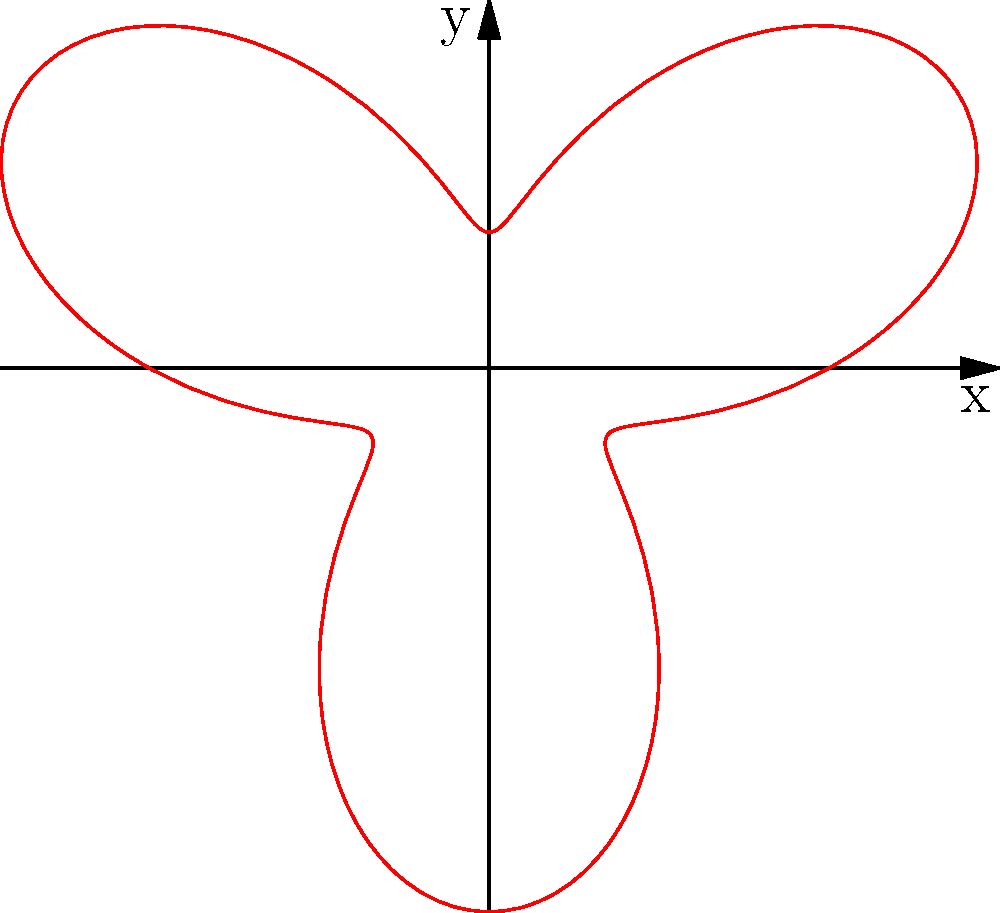In memory of your father, you plan to release a memorial balloon during a ceremony at the 9/11 Memorial. The balloon's trajectory can be modeled using the polar equation $r = 5 + 3\sin(3\theta)$, where $r$ is in meters and $\theta$ is in radians. What is the maximum distance, in meters, that the balloon will reach from the release point? To find the maximum distance the balloon will reach, we need to determine the maximum value of $r$ in the given polar equation.

1) The equation is $r = 5 + 3\sin(3\theta)$

2) The maximum value of $\sin(3\theta)$ is 1, which occurs when $3\theta = \frac{\pi}{2}, \frac{5\pi}{2}, \frac{9\pi}{2}$, etc.

3) When $\sin(3\theta) = 1$, the equation becomes:
   $r_{max} = 5 + 3(1) = 5 + 3 = 8$

4) Therefore, the maximum distance the balloon will reach from the release point is 8 meters.

This maximum distance occurs at regular intervals as the balloon spirals outward, creating a petal-like pattern as shown in the polar graph.
Answer: 8 meters 